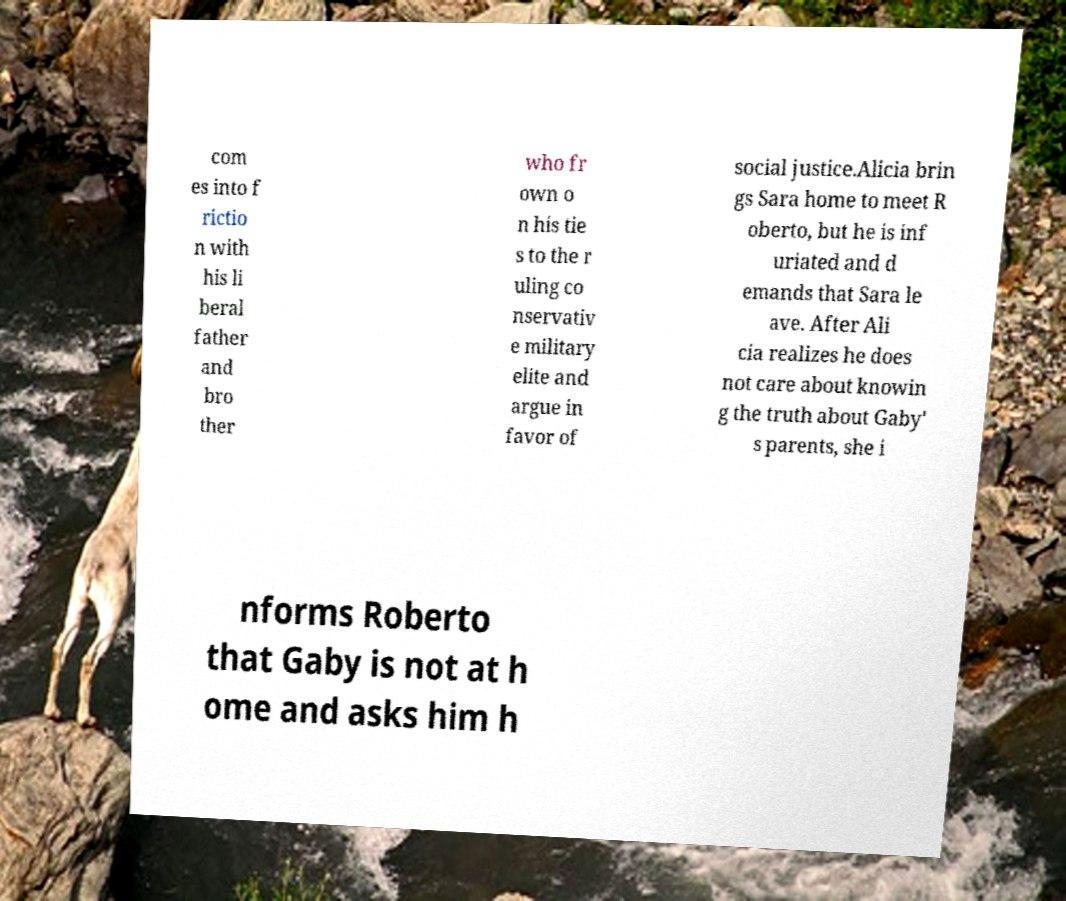I need the written content from this picture converted into text. Can you do that? com es into f rictio n with his li beral father and bro ther who fr own o n his tie s to the r uling co nservativ e military elite and argue in favor of social justice.Alicia brin gs Sara home to meet R oberto, but he is inf uriated and d emands that Sara le ave. After Ali cia realizes he does not care about knowin g the truth about Gaby' s parents, she i nforms Roberto that Gaby is not at h ome and asks him h 